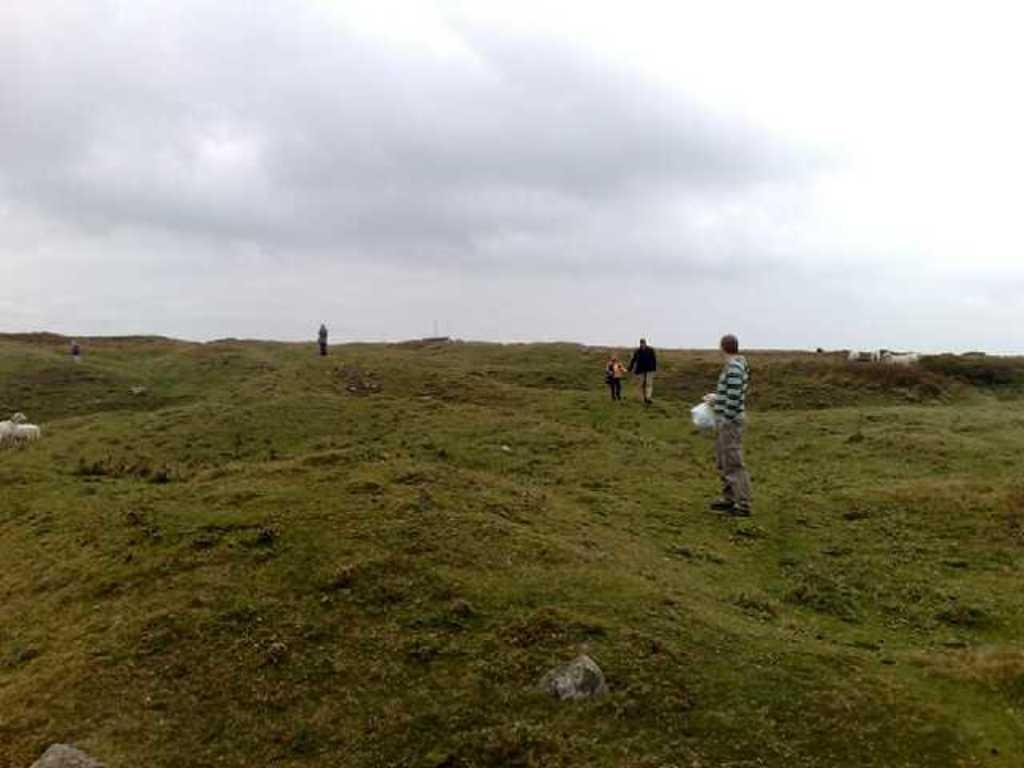Please provide a concise description of this image. In front of the picture, we see a man is standing. He is holding a white plastic bag in his hands. Here, we see two people are walking. In the background, we see a person is standing. On the left side, we see the dogs or sheep. On the right side, we see the cows. At the top, we see the sky. 